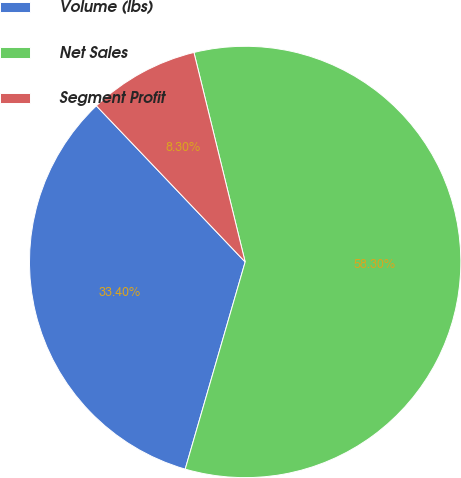Convert chart. <chart><loc_0><loc_0><loc_500><loc_500><pie_chart><fcel>Volume (lbs)<fcel>Net Sales<fcel>Segment Profit<nl><fcel>33.4%<fcel>58.3%<fcel>8.3%<nl></chart> 